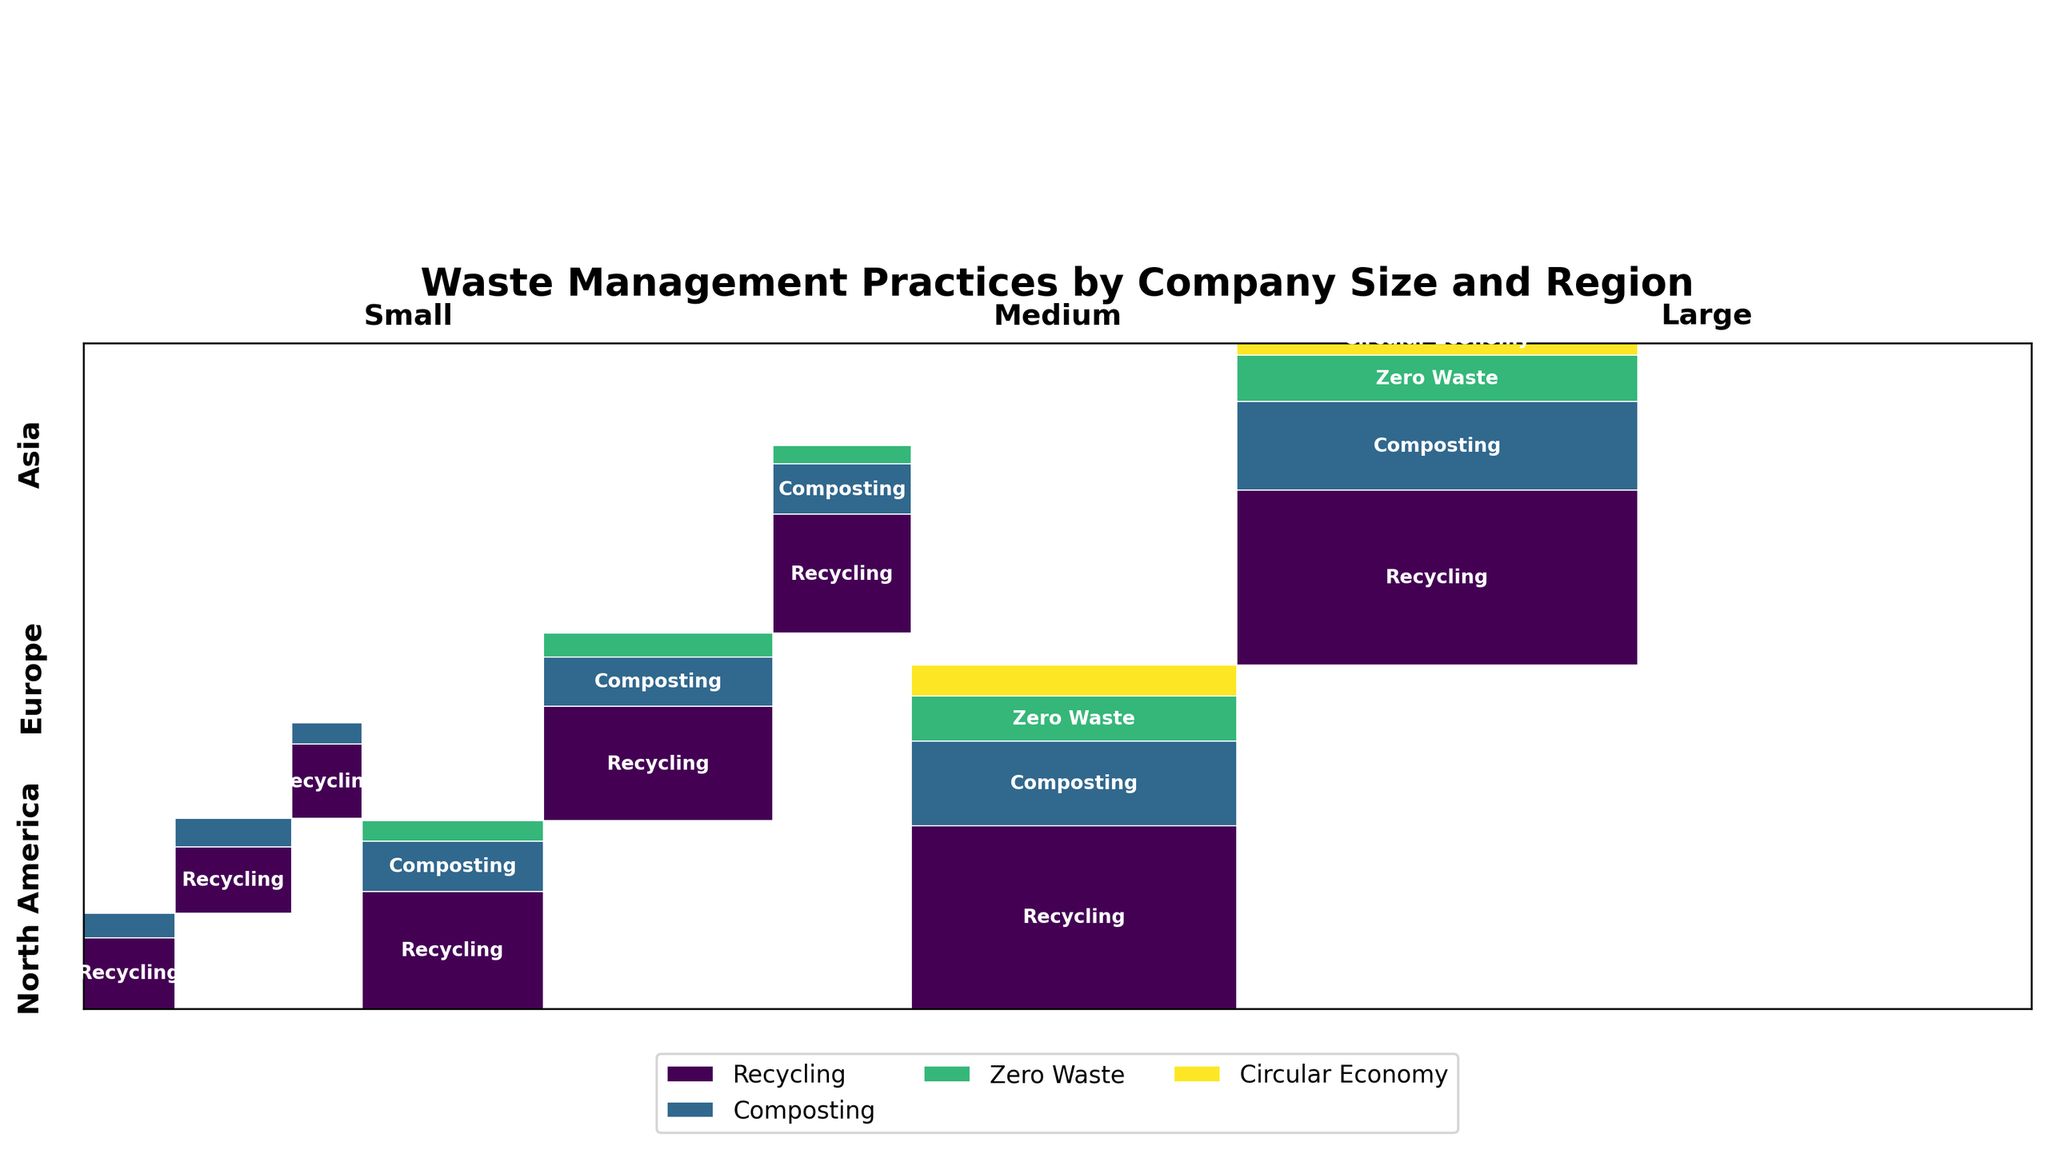What are the regions shown in the plot? The plot displays regions labeled on the y-axis. We have 'North America', 'Europe', and 'Asia' as regions.
Answer: North America, Europe, Asia How many waste management practices are shown in the plot for large companies? The legend identifies the waste management practices. There are four: 'Recycling', 'Composting', 'Zero Waste', and 'Circular Economy'.
Answer: 4 Which region has the most diverse waste management practices for medium-sized companies? For medium-sized companies, observe the number of distinct practices in each region. North America, Europe, and Asia each have shown practices like 'Recycling', 'Composting', and 'Zero Waste'. No region for medium-sized companies has more practices than the others.
Answer: Equal (North America, Europe, Asia) Which waste management practice is least adopted by small companies in Asia? Looking at the section for small companies in Asia, the practice with the smallest represented area is 'Composting'.
Answer: Composting What proportion of waste management practices in Europe are adopted by large companies for Circular Economy? The Europe section for large companies has four practices. Calculate the area corresponding to 'Circular Economy' out of the total area. It’s about 1 out of 4 noticeable sections, so roughly 25%.
Answer: 25% Which company size has the highest diversity in waste management practices across all regions? Observing the different waste management practices for each company size across regions, large companies have the most diverse, showing all four practices in multiple regions.
Answer: Large Is the Recycling practice more common in Europe than in North America across all company sizes? Compare the Recycling sections' total width for Europe and North America. Europe has larger cumulative widths indicating higher adoption than North America.
Answer: Yes What's the total number of waste management practices depicted in the plot? Sum the number of distinct waste management practices across all regions and company sizes. Practices include 'Recycling', 'Composting', 'Zero Waste', and 'Circular Economy'.
Answer: 4 Which geographic region exhibits the largest adoption of Zero Waste practice for large companies? Look at the Zero Waste practice area within the large companies section across all regions. The section in Europe is noticeably larger than those in North America or Asia.
Answer: Europe 